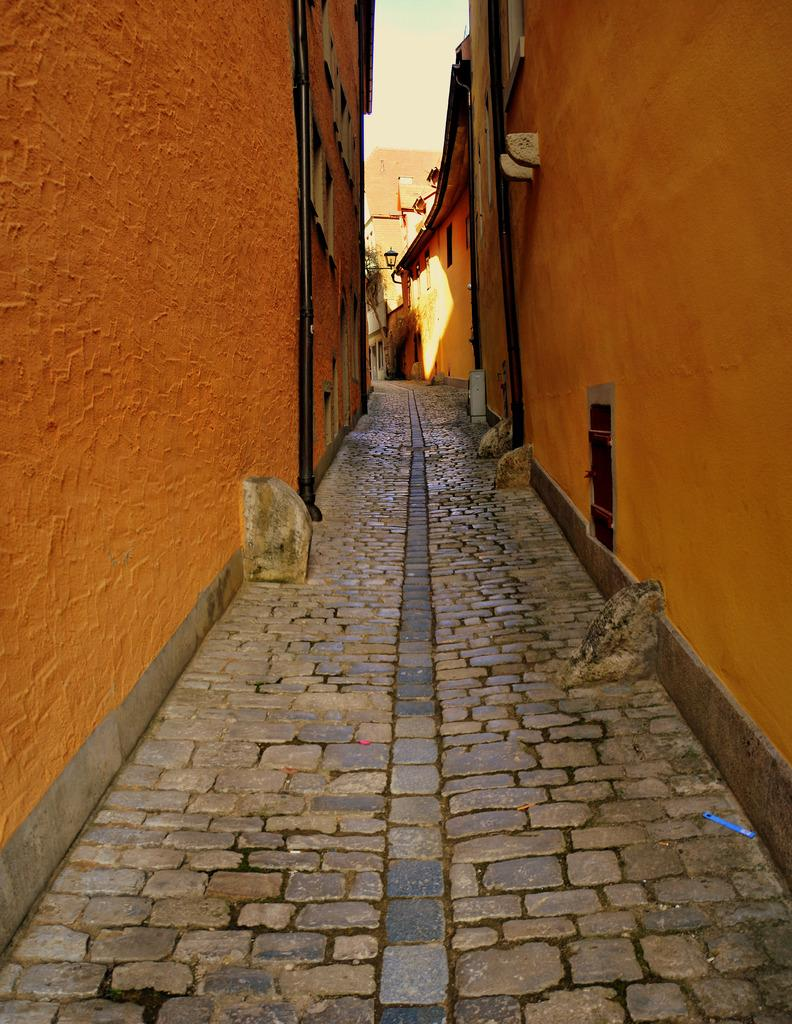What type of surface is visible in the image? There is a road in the image. How is the road constructed? The road is constructed with stones. What can be seen on either side of the road? There are two orange color buildings in the image. Where is the road located in relation to the buildings? The road is located between the two buildings. How many chickens are running around the club in the image? There are no chickens or clubs present in the image. 